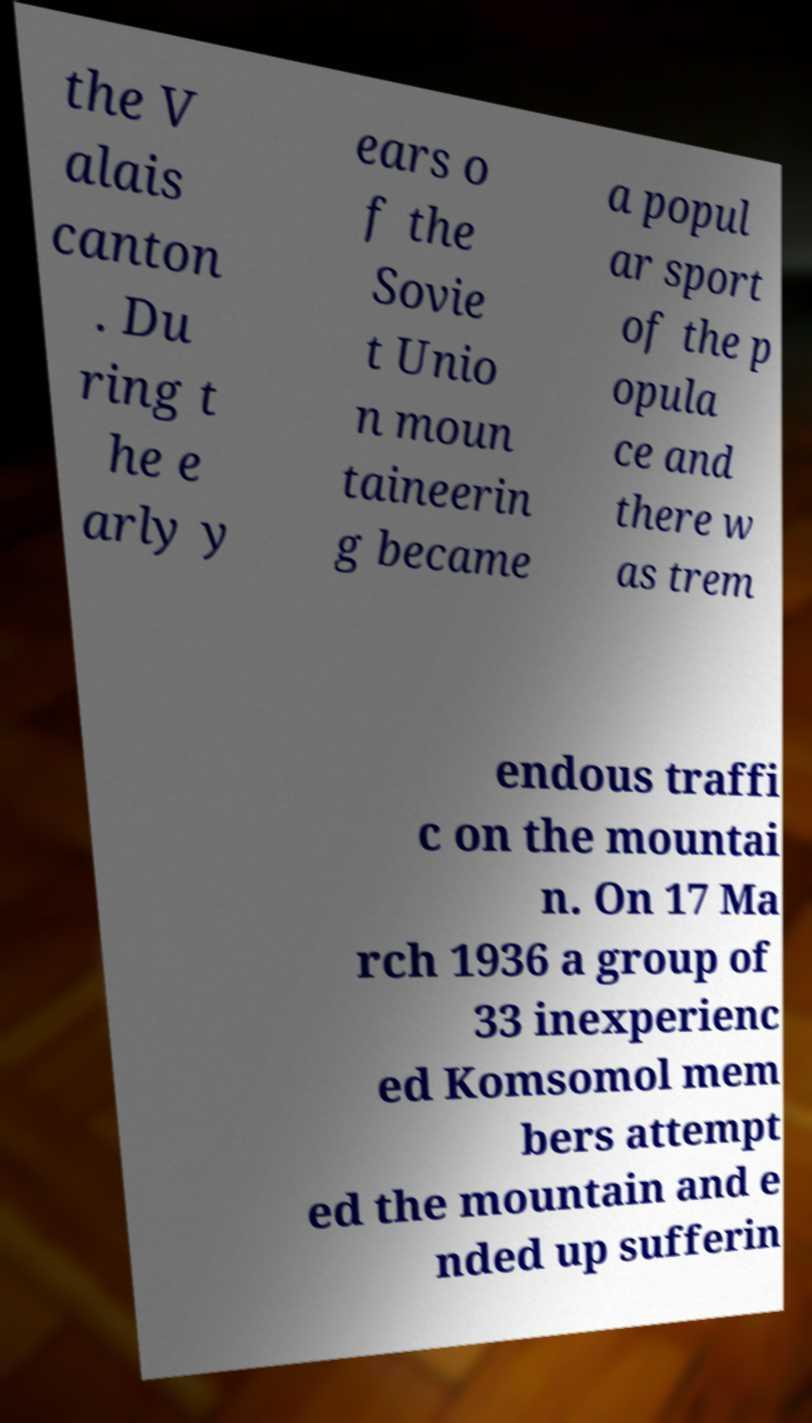Could you extract and type out the text from this image? the V alais canton . Du ring t he e arly y ears o f the Sovie t Unio n moun taineerin g became a popul ar sport of the p opula ce and there w as trem endous traffi c on the mountai n. On 17 Ma rch 1936 a group of 33 inexperienc ed Komsomol mem bers attempt ed the mountain and e nded up sufferin 